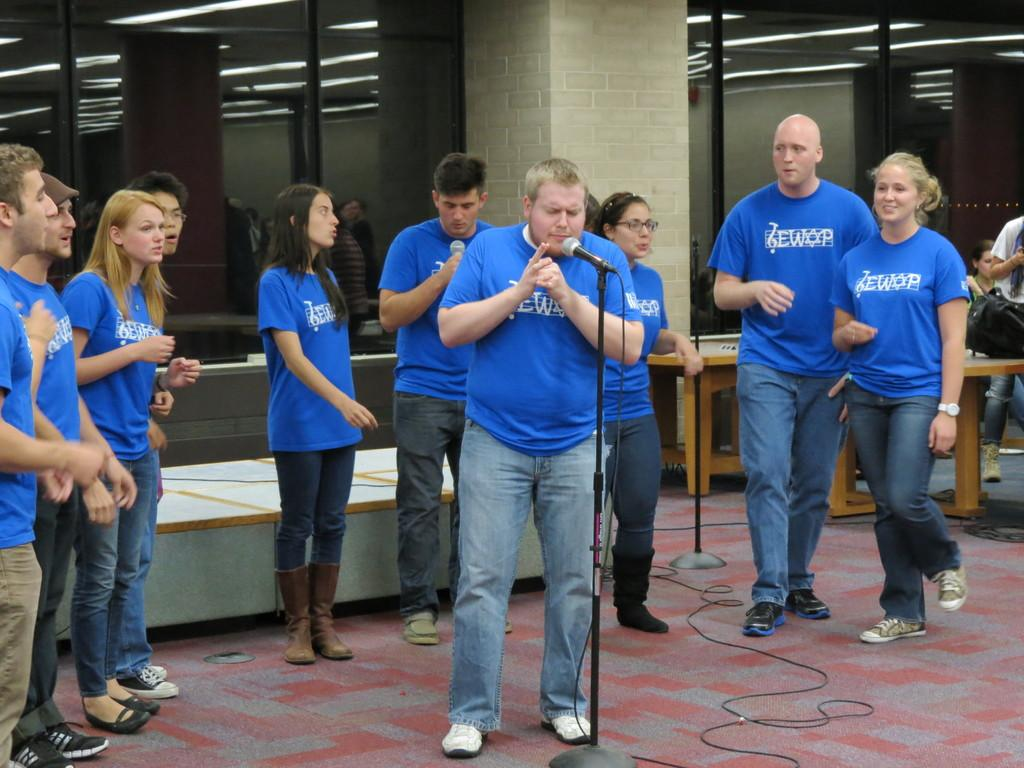What color are the shirts worn by the people in the image? The people in the image are wearing blue color shirts. What is the person in front of the microphone doing? The person is standing in front of a microphone. What are the other people in the image doing? The other people are sitting in the image. What type of furniture is present in the image? There are tables present in the image. How many books are stacked on the table in the image? There are no books visible in the image. What shape is the match that is being used by the person standing in front of the microphone? There is no match present in the image. 